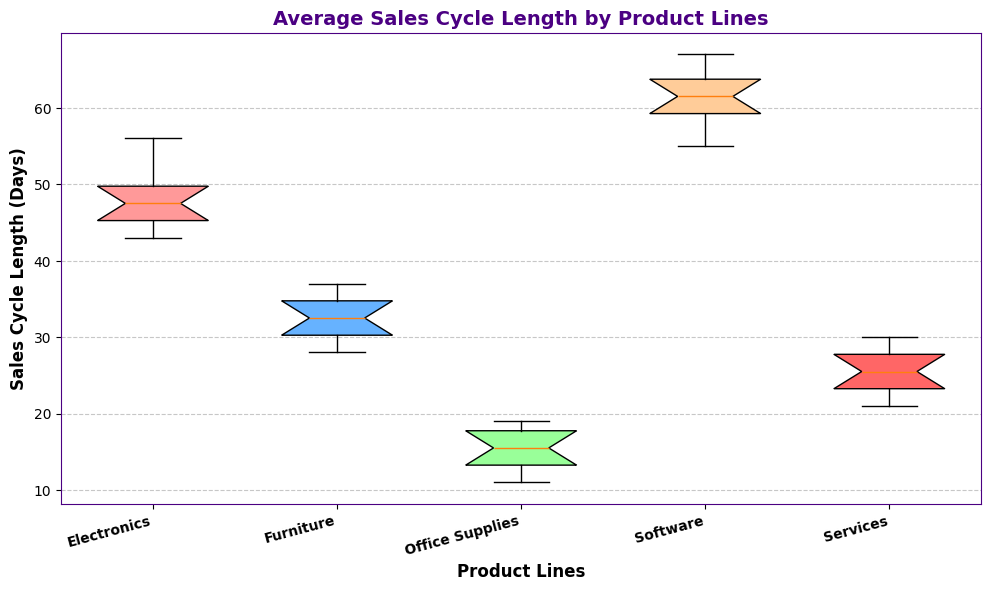What's the median sales cycle length for Electronics? The median is the middle value of the data set when ordered. In the box plot, this is represented by the line within the box for the Electronics product line.
Answer: 48 Which product line has the shortest minimum sales cycle length? The shortest minimum is identified by the lowest whisker on the box plot. Office Supplies has the lowest minimum sales cycle length.
Answer: Office Supplies Which product line has the widest interquartile range (IQR)? The IQR is the range between the first quartile (lower boundary of the box) and the third quartile (upper boundary of the box). The Software product line appears to have the widest IQR.
Answer: Software Is the range of sales cycle lengths for Furniture longer or shorter than that for Services? The range is determined by the distance between the minimum and maximum whiskers. Comparing the widths of the whiskers, Furniture has a shorter range than Services.
Answer: Shorter What is the median sales cycle length for Services and how does it compare to the median for Furniture? The median is found by the central line in each box. The median for Services can be directly compared to that for Furniture by observing these lines. Services' median is higher than that of Furniture.
Answer: Services' median is higher Which product line has the lowest third quartile value? The third quartile value is the upper boundary of the box in the boxplot. Office Supplies has the lowest third quartile value.
Answer: Office Supplies Compare the median sales cycle length of Software to Electronics. Which is higher? The median line inside each product line's box indicates the median value. The Software median appears to be higher than that for Electronics.
Answer: Software is higher Which product line shows the most consistent (least variable) sales cycle length? Consistency or less variability is shown by the smallest distance between the whiskers and the smallest IQR. Office Supplies appears the most consistent.
Answer: Office Supplies What is the median sales cycle length for each product line? The boxplot shows the median as a line inside each box for each product line. Identify and read the values for each product line from the figure.
Answer: Electronics: 48, Furniture: 32.5, Office Supplies: 15, Software: 61.5, Services: 25 